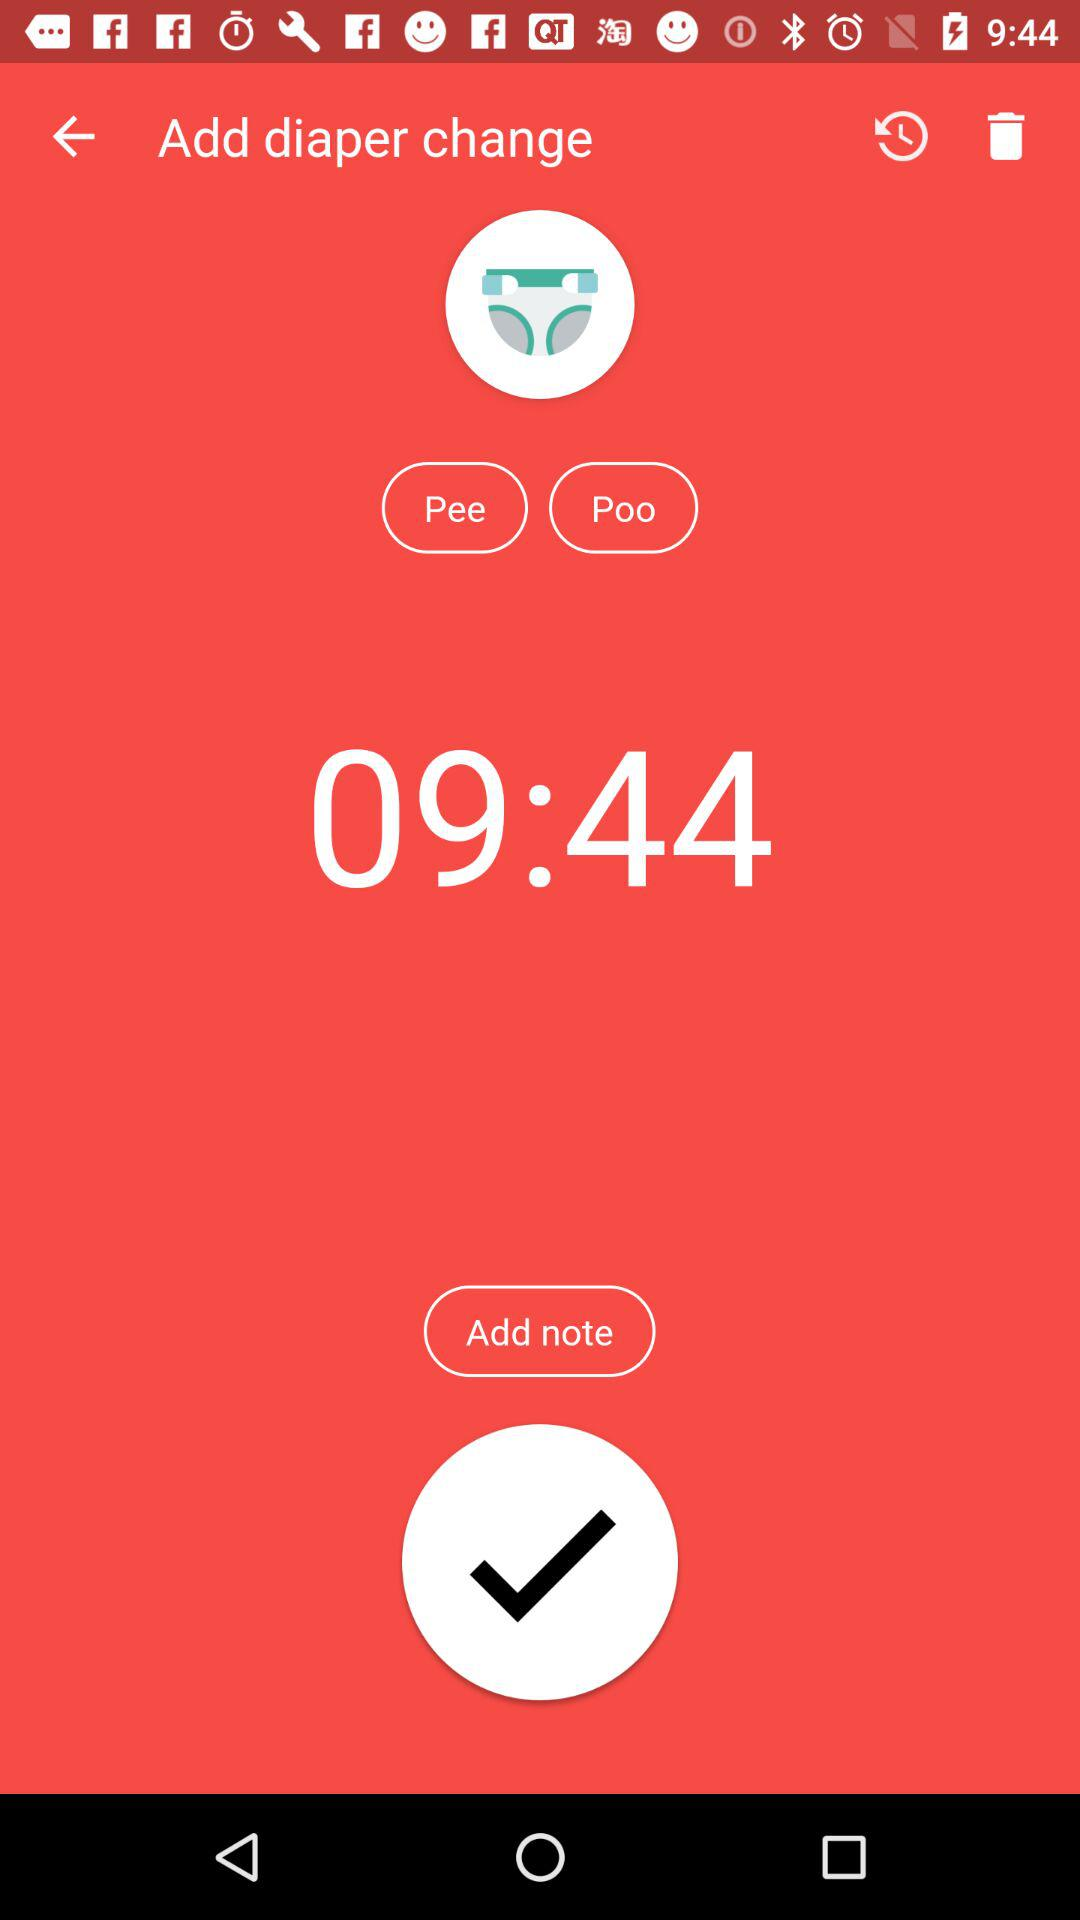What is the time shown on the screen? The time shown on the screen is 09:44. 